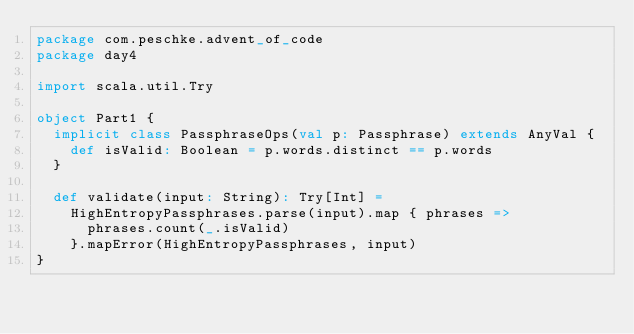<code> <loc_0><loc_0><loc_500><loc_500><_Scala_>package com.peschke.advent_of_code
package day4

import scala.util.Try

object Part1 {
  implicit class PassphraseOps(val p: Passphrase) extends AnyVal {
    def isValid: Boolean = p.words.distinct == p.words
  }

  def validate(input: String): Try[Int] =
    HighEntropyPassphrases.parse(input).map { phrases =>
      phrases.count(_.isValid)
    }.mapError(HighEntropyPassphrases, input)
}
</code> 